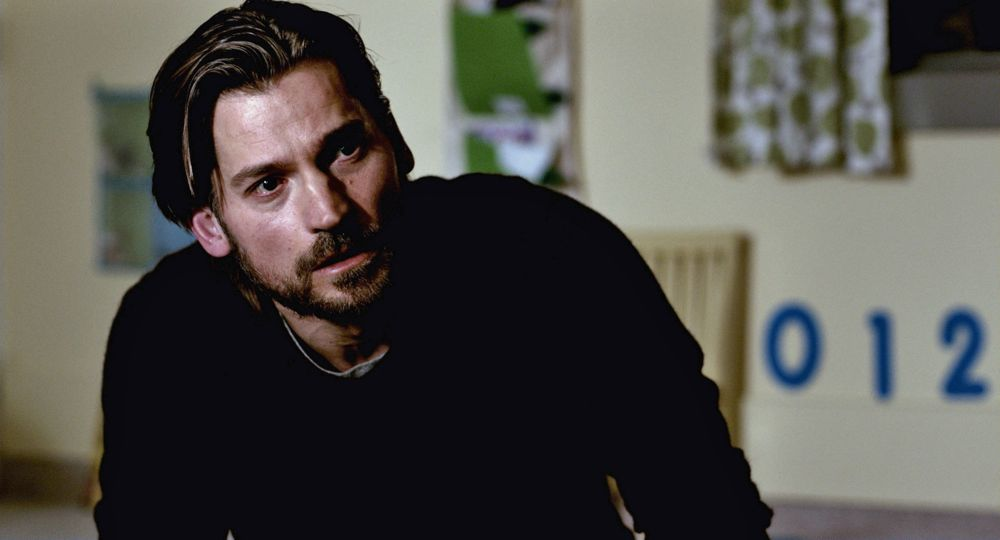If you could create a backstory, what would it be? The man in the image is a single father named Alex who recently moved to a small town seeking a fresh start for himself and his young daughter, Lily. The picture captures a moment where Alex is in a daycare center, having a critical conversation with Lily's teacher. The numbers '012' are part of the learning materials in the center, symbolizing the early stages of Lily's education. Alex's serious demeanor reflects his concern for his daughter's adjustment to the new environment, and he is deeply engaged in understanding how she is coping with the change. As a dedicated father, he is determined to provide the best for Lily, and this moment captures his silent resolve to ensure her happiness and well-being in their new life. Imagine a dramatic event happening next in this scene. Suddenly, the sound of breaking glass shatters the quiet ambiance of the room. Alex and the teacher quickly turn towards the source of the noise, their expressions shifting from contemplation to alarm. Outside the window, a scene of chaos unfolds as a large tree branch, weakened from a recent storm, crashes through the daycare’s playground. Alex’s immediate concern shifts from deep thought to protective action as he rushes to ensure that Lily and the other children are safe from harm. The daycare staff spring into emergency mode, evacuating the children efficiently while Alex's heart pounds with fear and adrenaline. This unexpected event starkly contrasts with the prior moment of introspection, highlighting the unpredictable nature of life and the depths of a parent's protective instincts. Write a very creative question about the image. If the man in the image were a time traveler who had just returned from a mission, what historical event might he be grappling with in his thoughts, and how does the room's setting with the numbers '012' contribute to this narrative? Describe a realistic scenario happening in this setting (short response). Alex is listening intently as the daycare teacher explains Lily's progress in learning numbers. The '012' on the wall are part of the materials used in their daily activities. Describe a realistic scenario happening in this setting (long response). Alex is seated in the daycare room, having a detailed conversation with Lily's teacher about her adaptation to the new daycare. The teacher, holding a folder with Lily’s drawings and assignments, explains how Lily has been responding to various activities designed to enhance her cognitive skills and social interaction. The ‘012’ on the wall are part of an educational display meant to help the children recognize and become familiar with numbers. Alex listens intently, his concern evident but mixed with a sense of pride as the teacher remarks on Lily’s quick learning and adaptability. This moment underscores Alex’s devotion to his daughter’s well-being and education, as he seeks to understand every aspect of her new environment to support her growth. 